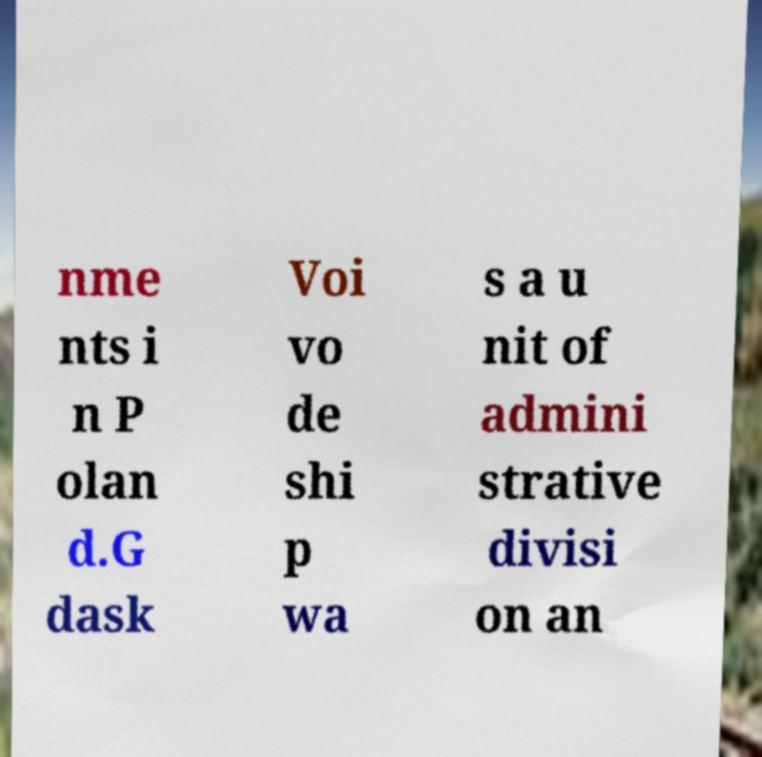I need the written content from this picture converted into text. Can you do that? nme nts i n P olan d.G dask Voi vo de shi p wa s a u nit of admini strative divisi on an 